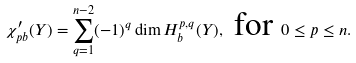<formula> <loc_0><loc_0><loc_500><loc_500>\chi _ { p b } ^ { \prime } ( Y ) = \sum _ { q = 1 } ^ { n - 2 } ( - 1 ) ^ { q } \dim H _ { b } ^ { p , q } ( Y ) , \text { for } 0 \leq p \leq n .</formula> 